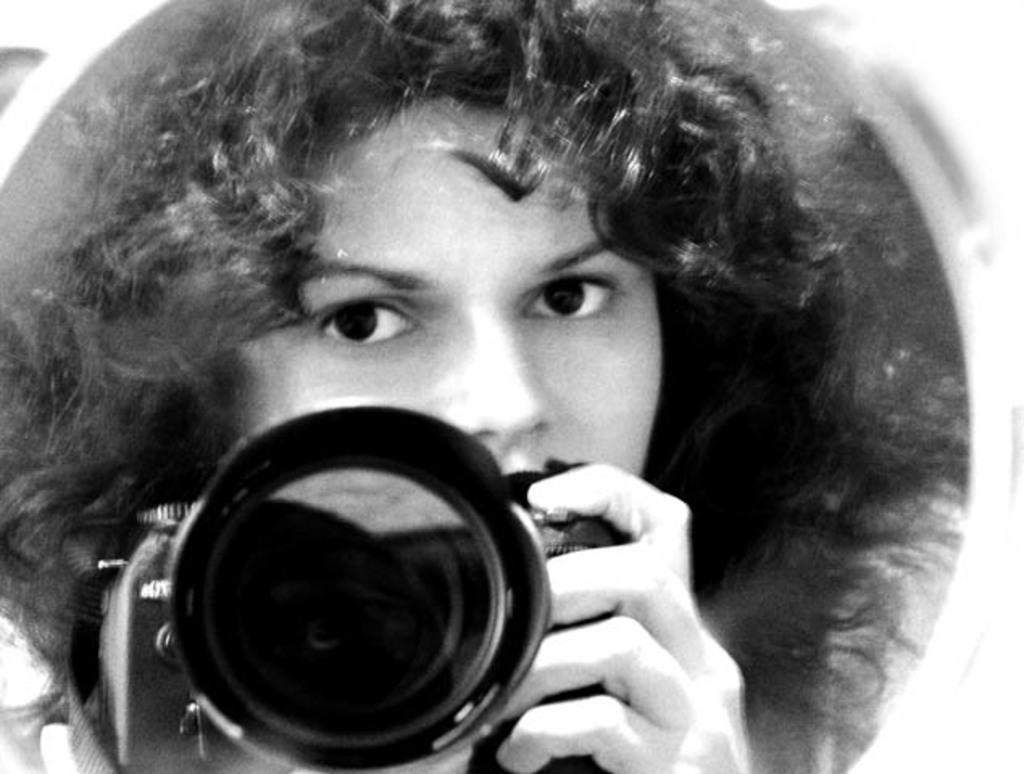What is the color scheme of the image? The image is black and white. Can you describe the person in the image? There is a person in the image. What is the person holding in the image? The person is holding a camera. Where is the dock located in the image? There is no dock present in the image. Can you tell me how many copies of the camera the person is holding? The person is holding only one camera, so there are no copies present. 